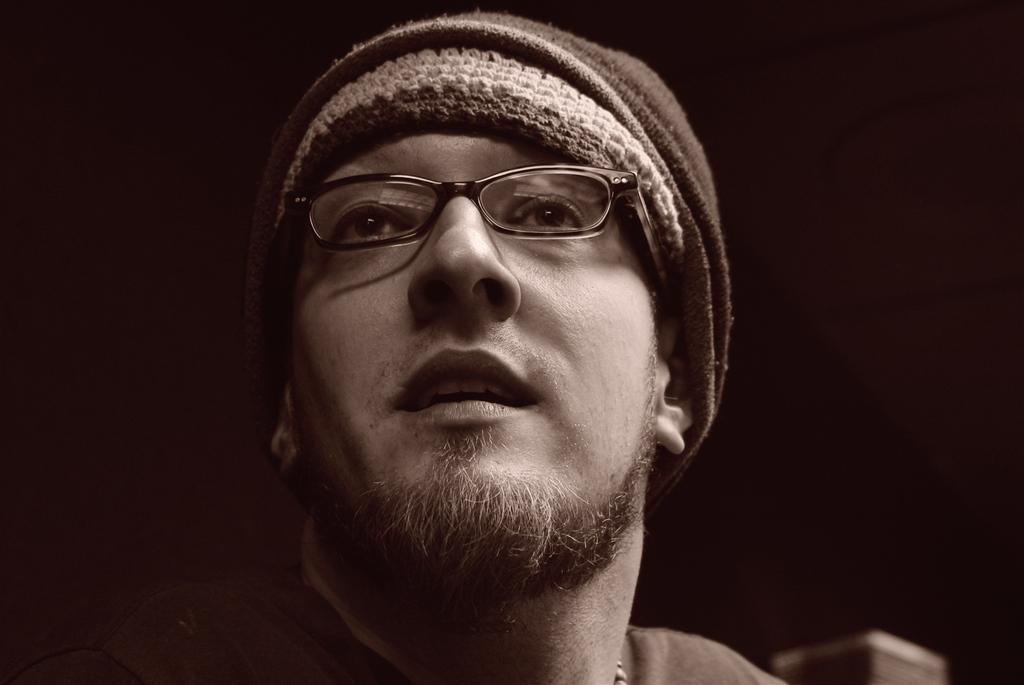How would you summarize this image in a sentence or two? It is a black and white image, in this a man is looking at his side he wore spectacles and a cap. 